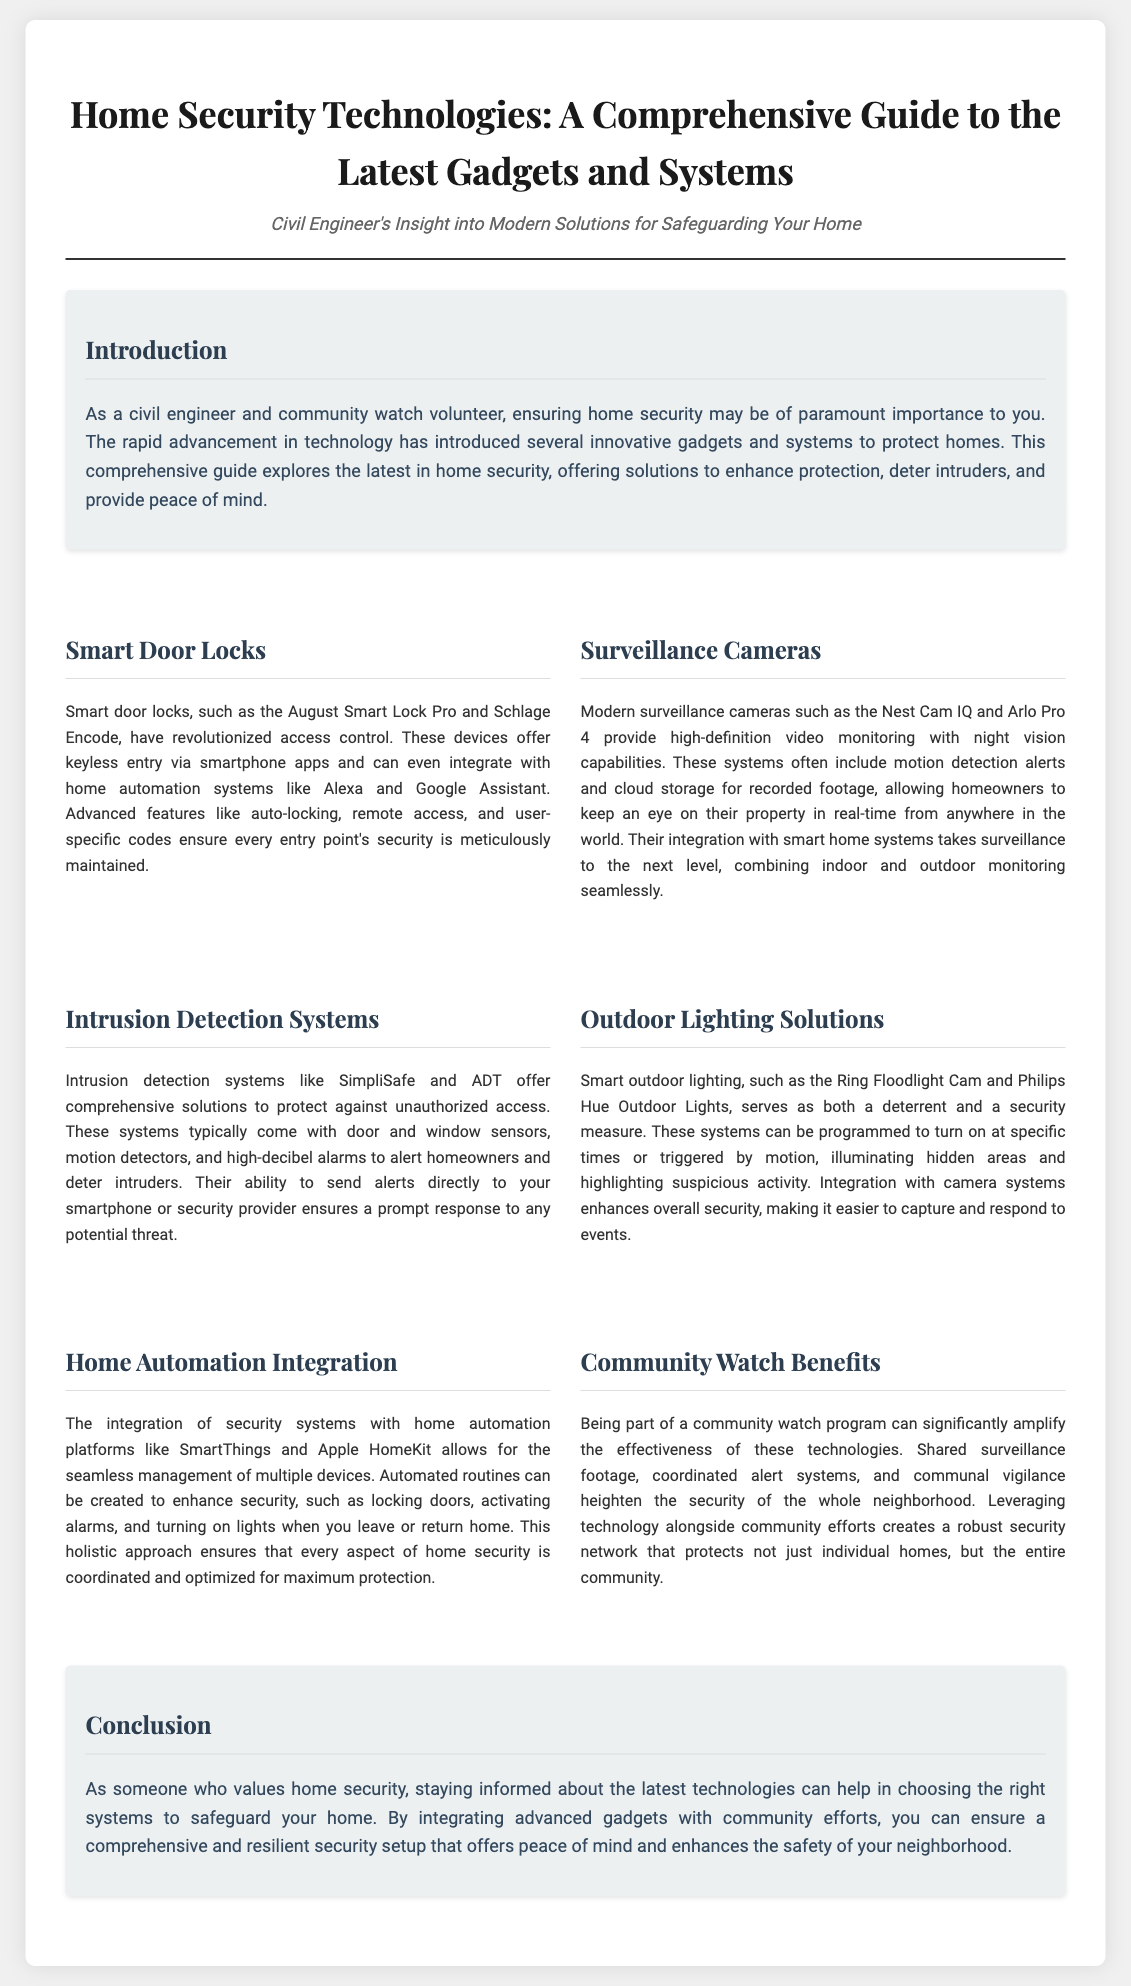What does the guide focus on? The guide focuses on the latest gadgets and systems for home security, providing insights into various technologies available for safeguarding homes.
Answer: Home security technologies What is an example of a smart door lock mentioned? The document mentions specific products as examples of smart door locks, including August Smart Lock Pro and Schlage Encode.
Answer: August Smart Lock Pro Which surveillance camera offers night vision capabilities? The document indicates that the Nest Cam IQ provides high-definition video monitoring with night vision capabilities.
Answer: Nest Cam IQ What is an example of a community watch benefit? The document states that shared surveillance footage is one of the benefits of participating in a community watch program.
Answer: Shared surveillance footage Which integration platform is mentioned for home automation? The guide mentions SmartThings and Apple HomeKit as platforms for integrating security systems with home automation.
Answer: SmartThings How do intrusion detection systems alert homeowners? The systems come with high-decibel alarms to alert homeowners and deter intruders when potential threats are detected.
Answer: High-decibel alarms What does the conclusion emphasize about home security? The conclusion emphasizes the importance of staying informed about the latest technologies and integrating them with community efforts for effective home security.
Answer: Staying informed What type of layout does this guide utilize? The guide utilizes a newspaper layout, featuring structured sections and informative content regarding home security technologies.
Answer: Newspaper layout 